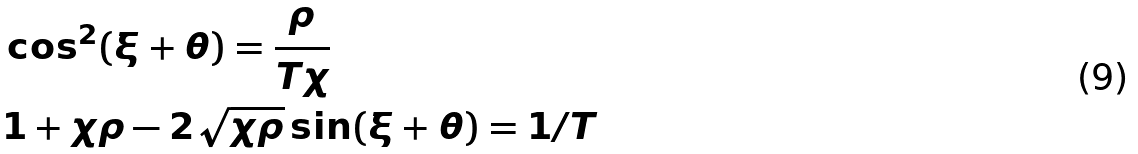Convert formula to latex. <formula><loc_0><loc_0><loc_500><loc_500>& \cos ^ { 2 } ( \xi + \theta ) = \frac { \rho } { T \chi } \\ & 1 + \chi \rho - 2 \sqrt { \chi \rho } \sin ( \xi + \theta ) = 1 / T</formula> 